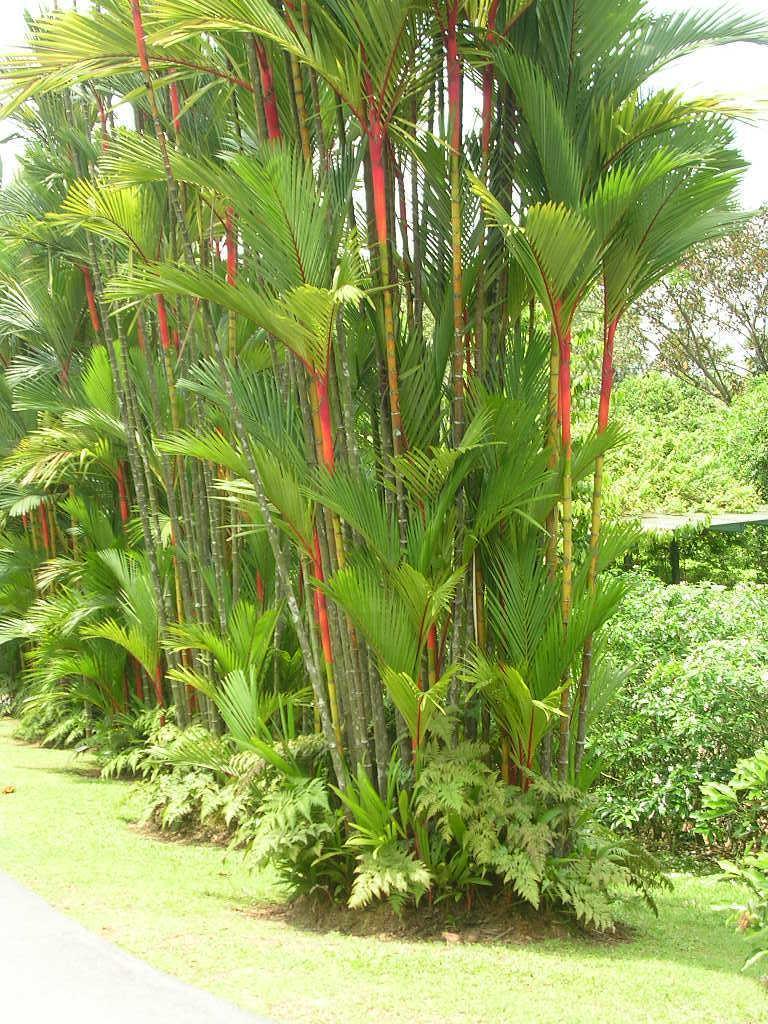Could you give a brief overview of what you see in this image? This image consists of plants and bushes at the bottom. There are trees in the middle. 